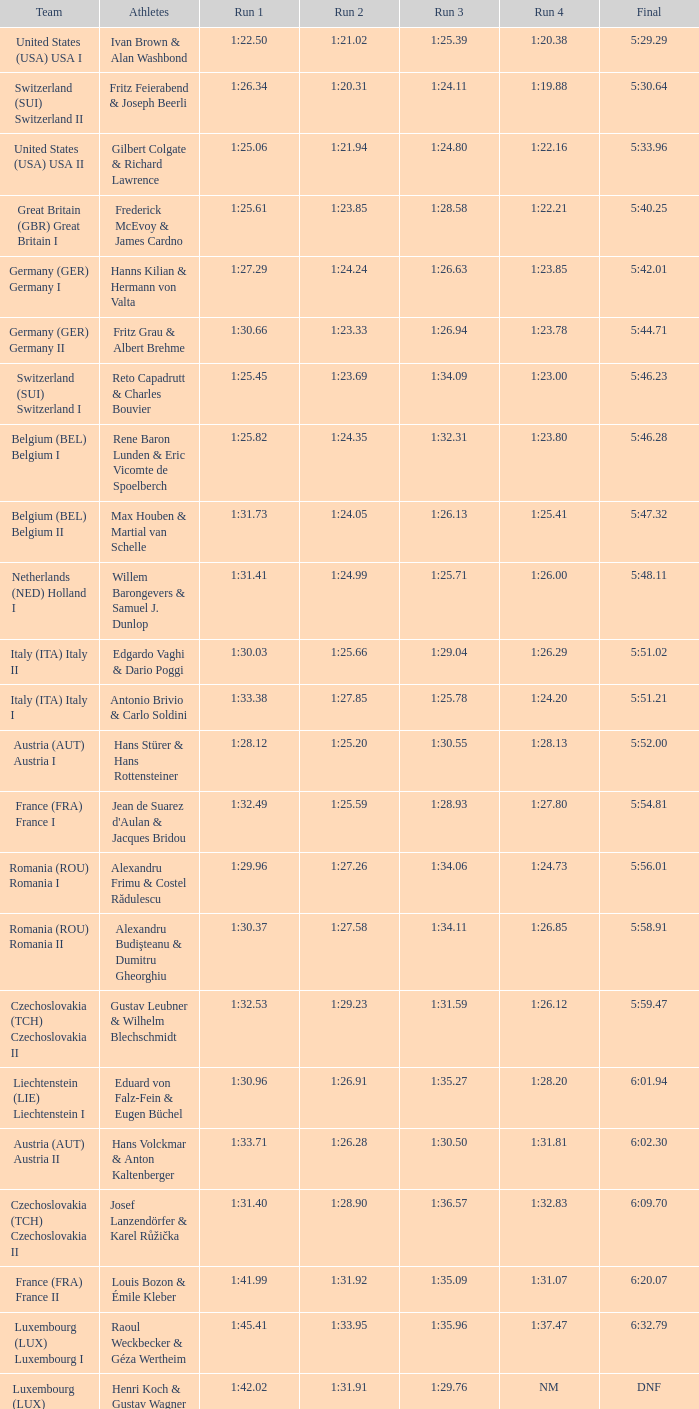Which championship includes a liechtenstein (lie) team in the final? 6:01.94. 